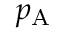Convert formula to latex. <formula><loc_0><loc_0><loc_500><loc_500>p _ { A }</formula> 